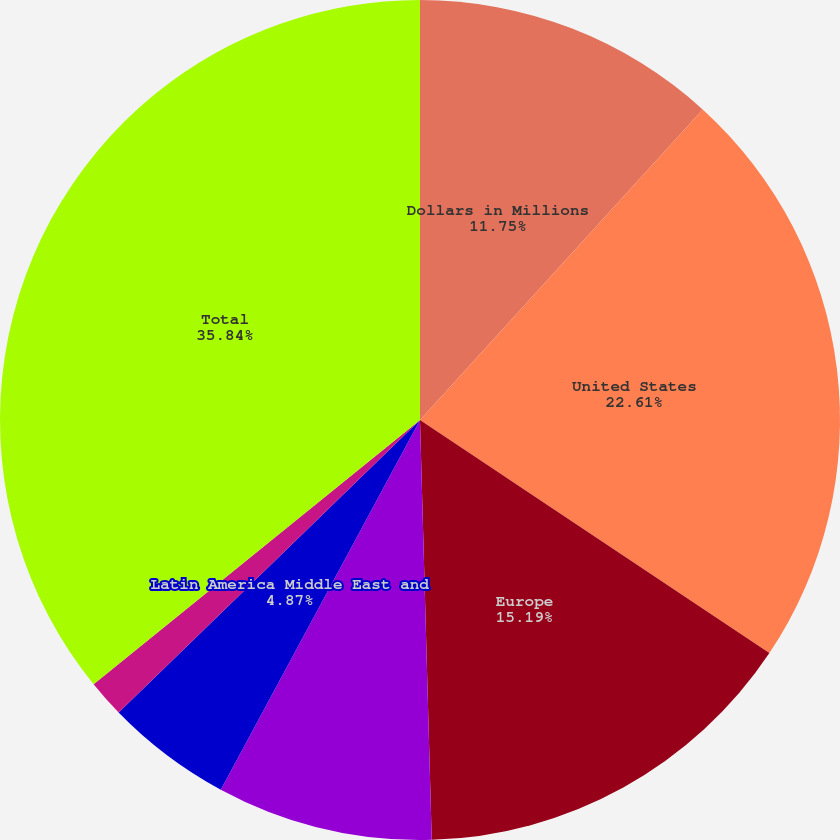Convert chart. <chart><loc_0><loc_0><loc_500><loc_500><pie_chart><fcel>Dollars in Millions<fcel>United States<fcel>Europe<fcel>Japan Asia Pacific and Canada<fcel>Latin America Middle East and<fcel>Emerging Markets<fcel>Total<nl><fcel>11.75%<fcel>22.61%<fcel>15.19%<fcel>8.31%<fcel>4.87%<fcel>1.43%<fcel>35.83%<nl></chart> 